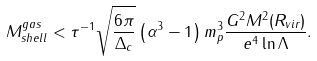Convert formula to latex. <formula><loc_0><loc_0><loc_500><loc_500>M ^ { g a s } _ { s h e l l } < \tau ^ { - 1 } \sqrt { \frac { 6 \pi } { \Delta _ { c } } } \left ( \alpha ^ { 3 } - 1 \right ) m ^ { 3 } _ { p } \frac { G ^ { 2 } M ^ { 2 } ( R _ { v i r } ) } { e ^ { 4 } \ln { \Lambda } } .</formula> 